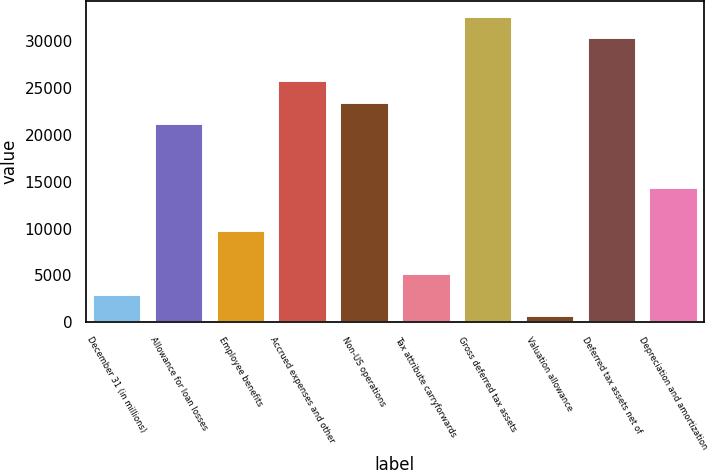Convert chart. <chart><loc_0><loc_0><loc_500><loc_500><bar_chart><fcel>December 31 (in millions)<fcel>Allowance for loan losses<fcel>Employee benefits<fcel>Accrued expenses and other<fcel>Non-US operations<fcel>Tax attribute carryforwards<fcel>Gross deferred tax assets<fcel>Valuation allowance<fcel>Deferred tax assets net of<fcel>Depreciation and amortization<nl><fcel>3019.6<fcel>21296.4<fcel>9873.4<fcel>25865.6<fcel>23581<fcel>5304.2<fcel>32719.4<fcel>735<fcel>30434.8<fcel>14442.6<nl></chart> 